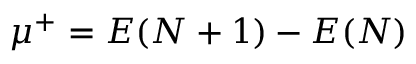<formula> <loc_0><loc_0><loc_500><loc_500>\mu ^ { + } = E ( N + 1 ) - E ( N )</formula> 